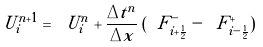Convert formula to latex. <formula><loc_0><loc_0><loc_500><loc_500>\ U _ { i } ^ { n + 1 } = \ U _ { i } ^ { n } + \frac { \Delta t ^ { n } } { \Delta x } \, ( \ F _ { i + \frac { 1 } { 2 } } ^ { - } - \ F _ { i - \frac { 1 } { 2 } } ^ { + } )</formula> 